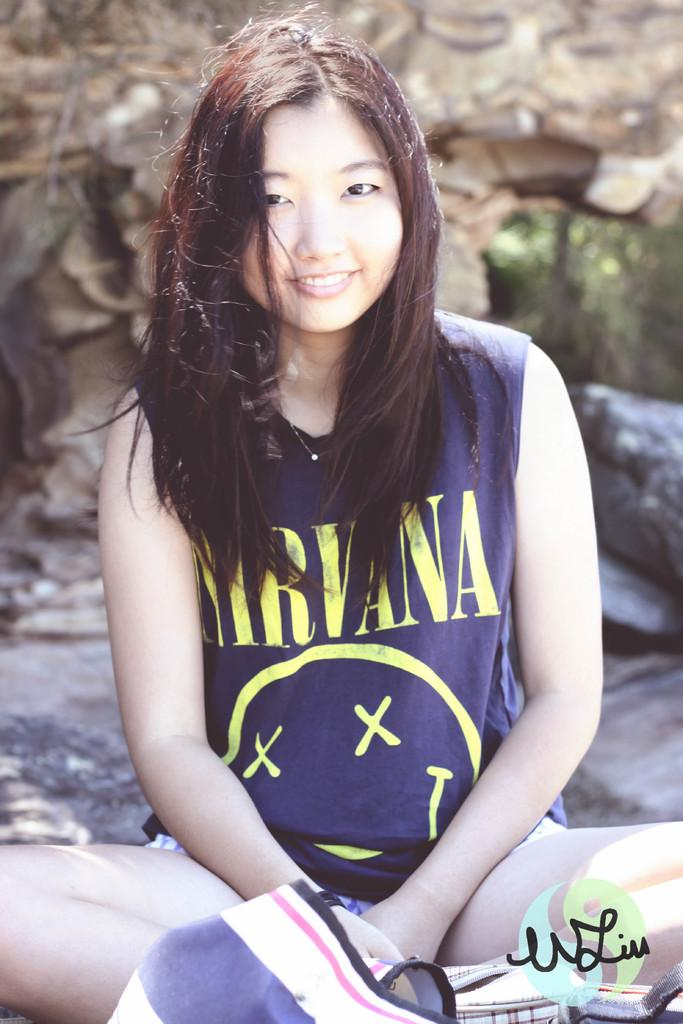What is the woman in the image doing? The woman is sitting on the ground in the image. What can be seen in the background of the image? There are rocks visible in the background of the image. What type of wire is being used by the farmer in the image? There is no farmer or wire present in the image; it only features a woman sitting on the ground with rocks in the background. 